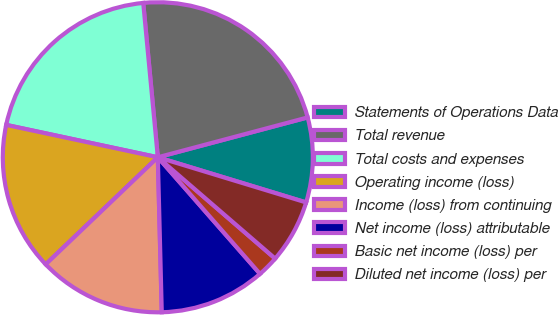Convert chart. <chart><loc_0><loc_0><loc_500><loc_500><pie_chart><fcel>Statements of Operations Data<fcel>Total revenue<fcel>Total costs and expenses<fcel>Operating income (loss)<fcel>Income (loss) from continuing<fcel>Net income (loss) attributable<fcel>Basic net income (loss) per<fcel>Diluted net income (loss) per<nl><fcel>8.84%<fcel>22.36%<fcel>20.15%<fcel>15.48%<fcel>13.27%<fcel>11.05%<fcel>2.21%<fcel>6.63%<nl></chart> 